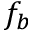Convert formula to latex. <formula><loc_0><loc_0><loc_500><loc_500>f _ { b }</formula> 